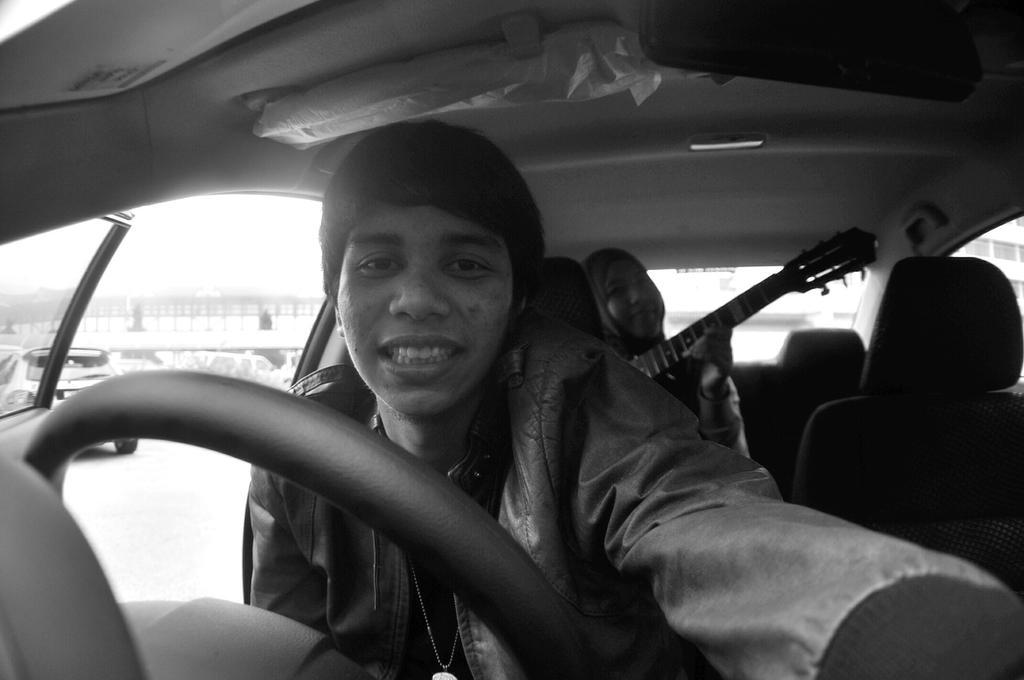How would you summarize this image in a sentence or two? In this picture we can see person wore jacket and smiling and at back of her we can see other person holding guitar in her hand and they both of them are smiling and they are inside the vehicle and in background we can see car, bridge. 